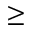<formula> <loc_0><loc_0><loc_500><loc_500>\geq</formula> 